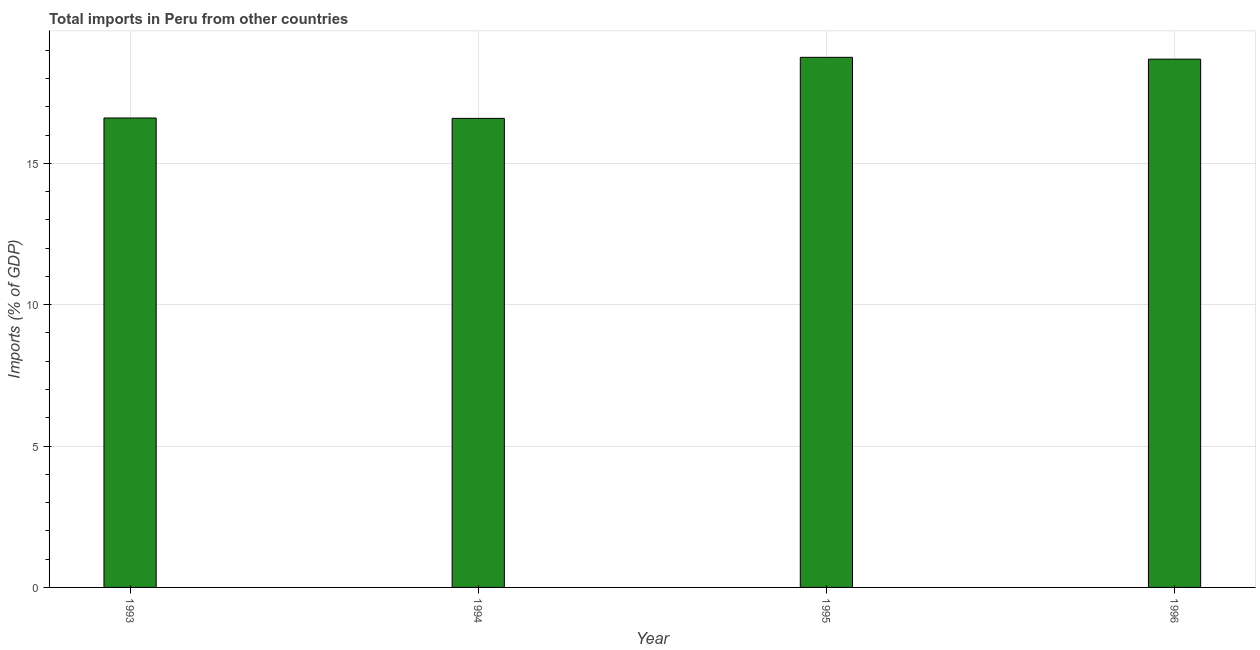What is the title of the graph?
Provide a short and direct response. Total imports in Peru from other countries. What is the label or title of the Y-axis?
Offer a very short reply. Imports (% of GDP). What is the total imports in 1995?
Give a very brief answer. 18.75. Across all years, what is the maximum total imports?
Your response must be concise. 18.75. Across all years, what is the minimum total imports?
Ensure brevity in your answer.  16.59. In which year was the total imports maximum?
Make the answer very short. 1995. What is the sum of the total imports?
Provide a succinct answer. 70.63. What is the difference between the total imports in 1994 and 1995?
Offer a very short reply. -2.16. What is the average total imports per year?
Your response must be concise. 17.66. What is the median total imports?
Give a very brief answer. 17.65. In how many years, is the total imports greater than 2 %?
Offer a very short reply. 4. Do a majority of the years between 1994 and 1996 (inclusive) have total imports greater than 6 %?
Offer a very short reply. Yes. What is the ratio of the total imports in 1995 to that in 1996?
Your response must be concise. 1. What is the difference between the highest and the second highest total imports?
Ensure brevity in your answer.  0.07. What is the difference between the highest and the lowest total imports?
Ensure brevity in your answer.  2.16. In how many years, is the total imports greater than the average total imports taken over all years?
Your answer should be very brief. 2. How many years are there in the graph?
Give a very brief answer. 4. What is the Imports (% of GDP) in 1993?
Keep it short and to the point. 16.6. What is the Imports (% of GDP) of 1994?
Keep it short and to the point. 16.59. What is the Imports (% of GDP) of 1995?
Keep it short and to the point. 18.75. What is the Imports (% of GDP) in 1996?
Your answer should be compact. 18.69. What is the difference between the Imports (% of GDP) in 1993 and 1994?
Make the answer very short. 0.01. What is the difference between the Imports (% of GDP) in 1993 and 1995?
Keep it short and to the point. -2.15. What is the difference between the Imports (% of GDP) in 1993 and 1996?
Offer a very short reply. -2.08. What is the difference between the Imports (% of GDP) in 1994 and 1995?
Your answer should be very brief. -2.16. What is the difference between the Imports (% of GDP) in 1994 and 1996?
Provide a short and direct response. -2.09. What is the difference between the Imports (% of GDP) in 1995 and 1996?
Provide a short and direct response. 0.06. What is the ratio of the Imports (% of GDP) in 1993 to that in 1994?
Your answer should be very brief. 1. What is the ratio of the Imports (% of GDP) in 1993 to that in 1995?
Give a very brief answer. 0.89. What is the ratio of the Imports (% of GDP) in 1993 to that in 1996?
Offer a terse response. 0.89. What is the ratio of the Imports (% of GDP) in 1994 to that in 1995?
Your answer should be compact. 0.89. What is the ratio of the Imports (% of GDP) in 1994 to that in 1996?
Keep it short and to the point. 0.89. 